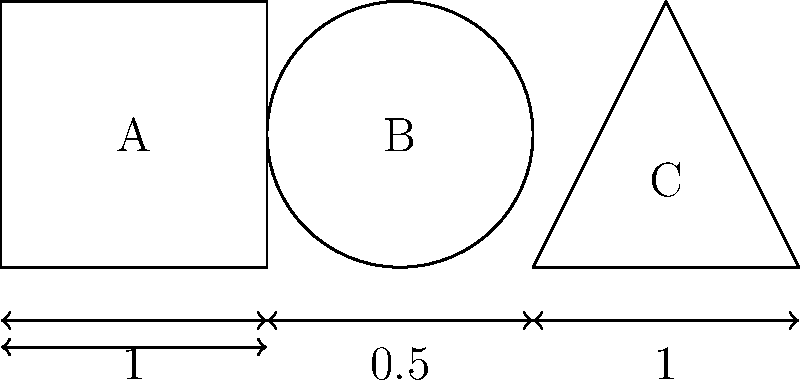In the context of structural engineering, consider three column shapes: a square (A), a circle (B), and an equilateral triangle (C). If all three columns have the same height and the dimensions shown in the figure, which shape has the largest cross-sectional area? How might this relate to the column's ability to support vertical loads in a narrative structure? To determine which shape has the largest cross-sectional area, we need to calculate the area of each shape:

1. Square (A):
   Area = side² = 1² = 1 unit²

2. Circle (B):
   Area = πr² = π(0.5)² = 0.25π ≈ 0.785 unit²

3. Equilateral Triangle (C):
   Area = (√3/4) * side² = (√3/4) * 1² ≈ 0.433 unit²

Comparing the areas:
Square (1) > Circle (0.785) > Triangle (0.433)

The square has the largest cross-sectional area.

In the context of oral literature and storytelling, this concept can be related to the structural integrity of a narrative:

1. The square column (largest area) represents a well-structured, balanced story with strong supporting elements on all sides.
2. The circular column symbolizes a story that flows smoothly but may lack the defined edges of a square narrative.
3. The triangular column, with the smallest area, could represent a minimalist narrative structure that relies on three key elements or plot points.

Just as a column with a larger cross-sectional area can support more weight, a story with a more robust structure (like the square) can potentially carry more complex themes, characters, and plot elements without losing its integrity.
Answer: The square column (A) has the largest cross-sectional area. 